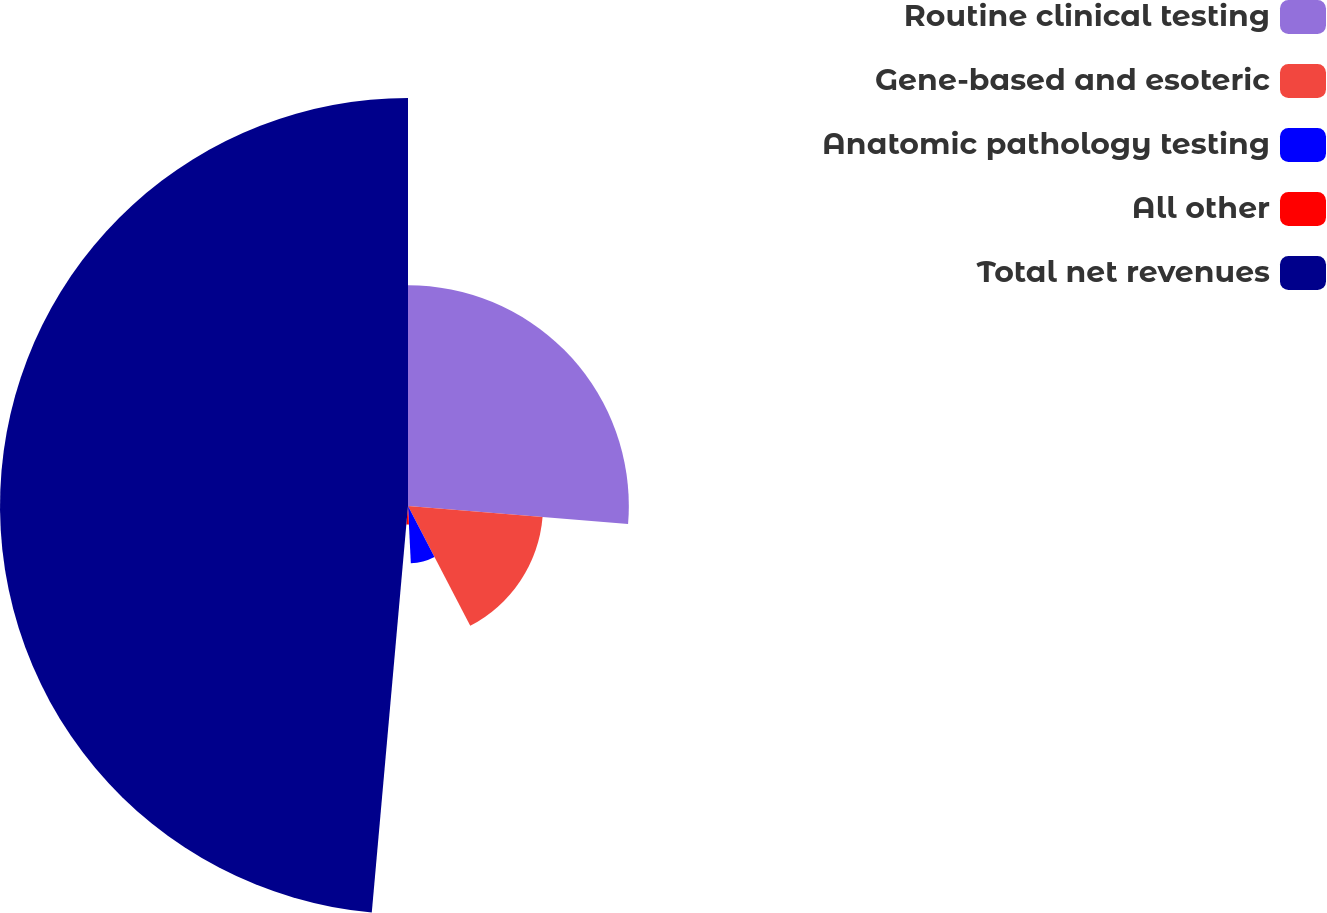Convert chart to OTSL. <chart><loc_0><loc_0><loc_500><loc_500><pie_chart><fcel>Routine clinical testing<fcel>Gene-based and esoteric<fcel>Anatomic pathology testing<fcel>All other<fcel>Total net revenues<nl><fcel>26.3%<fcel>16.08%<fcel>6.84%<fcel>2.2%<fcel>48.59%<nl></chart> 